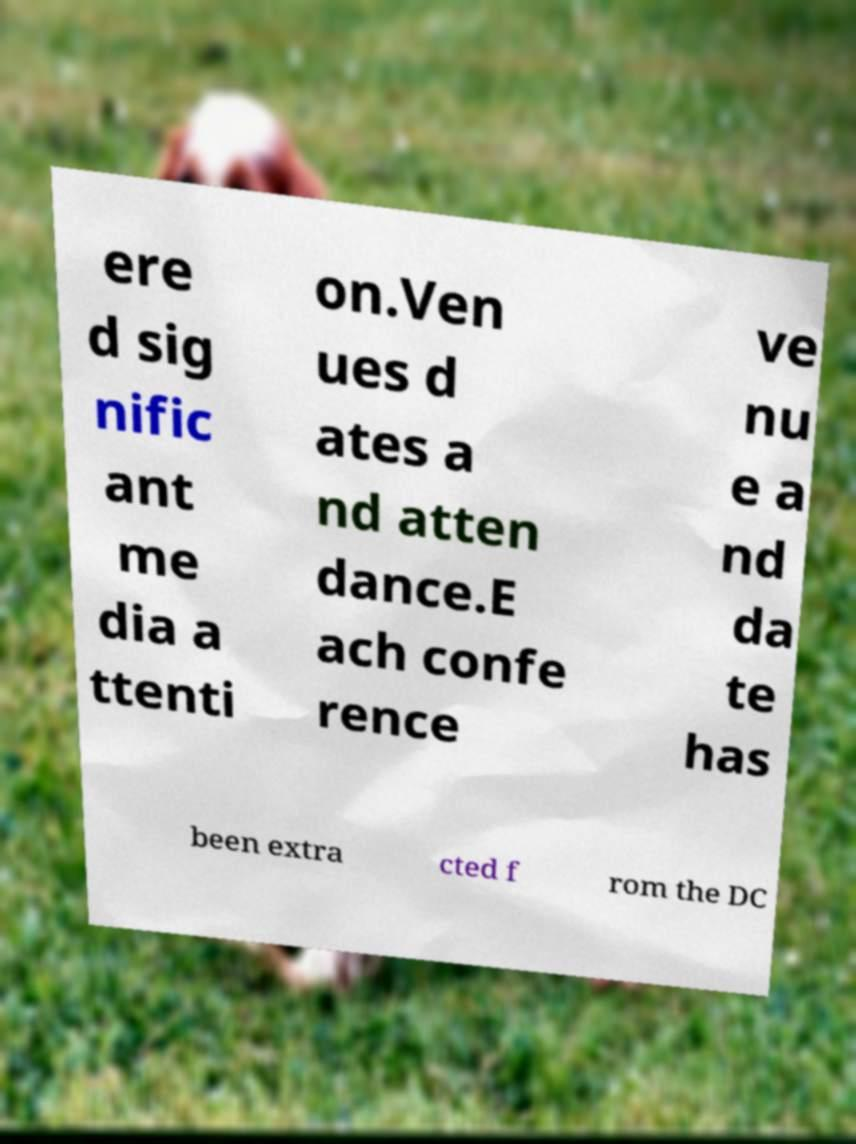Can you accurately transcribe the text from the provided image for me? ere d sig nific ant me dia a ttenti on.Ven ues d ates a nd atten dance.E ach confe rence ve nu e a nd da te has been extra cted f rom the DC 